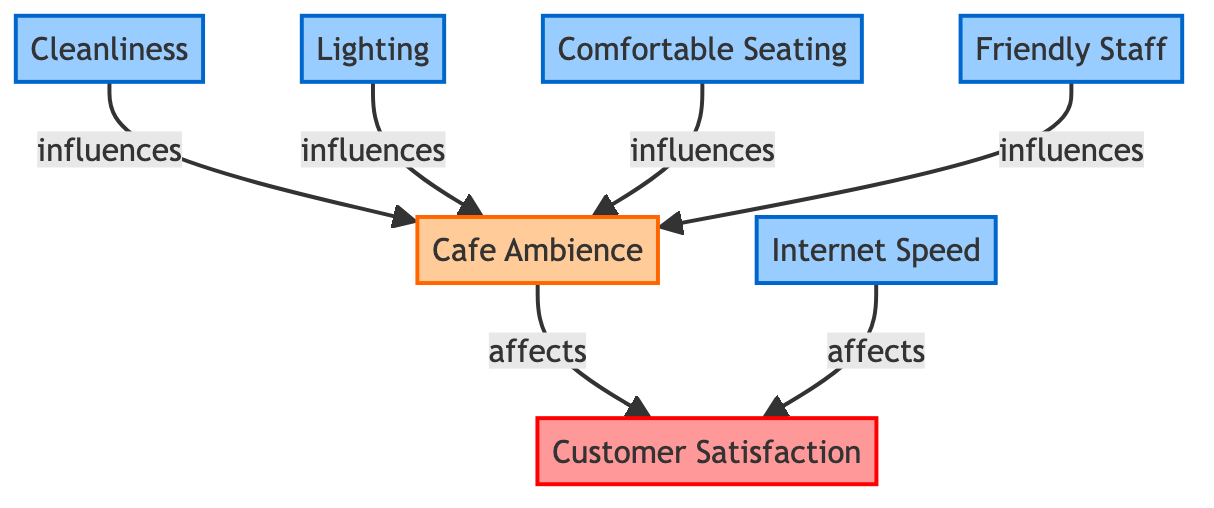What is the main outcome indicated in the diagram? The diagram indicates that "Customer Satisfaction" is the primary outcome at the top.
Answer: Customer Satisfaction How many factors influence the intermediate node "Cafe Ambience"? The diagram shows four factors that influence the intermediate node "Cafe Ambience": Cleanliness, Lighting, Comfortable Seating, and Friendly Staff.
Answer: Four Which factor directly affects "Customer Satisfaction"? The factors that directly affect "Customer Satisfaction" are "Internet Speed" and "Cafe Ambience," as indicated by the arrows leading to "Customer Satisfaction."
Answer: Internet Speed, Cafe Ambience What is the relationship between "Cleanliness" and "Customer Satisfaction"? "Cleanliness" influences "Cafe Ambience," which in turn affects "Customer Satisfaction," creating an indirect relationship through the intermediate node.
Answer: Indirect Which factor is indicated as influencing both "Cafe Ambience" and "Customer Satisfaction"? The factor "Internet Speed" affects "Customer Satisfaction" directly while "Cafe Ambience" is influenced by several factors, including "Lighting," suggesting a more significant role.
Answer: Internet Speed How many total nodes are represented in the diagram? The total nodes represented in the diagram are seven: Customer Satisfaction, Cleanliness, Lighting, Internet Speed, Comfortable Seating, Friendly Staff, and Cafe Ambience.
Answer: Seven Which two factors have a direct influence on the intermediate node? "Cleanliness" and "Lighting" both directly influence the intermediate node "Cafe Ambience."
Answer: Cleanliness, Lighting What color represents factors in the diagram? Factors in the diagram are represented by a blue color scheme, contrasting with the red for outcomes and orange for intermediate nodes.
Answer: Blue Which node appears at the top of the diagram? The node "Customer Satisfaction" appears at the top of the diagram, indicating it is the main outcome.
Answer: Customer Satisfaction 